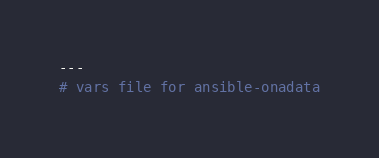Convert code to text. <code><loc_0><loc_0><loc_500><loc_500><_YAML_>---
# vars file for ansible-onadata
</code> 